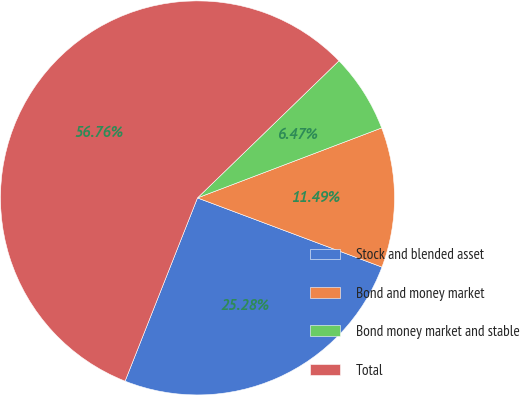Convert chart. <chart><loc_0><loc_0><loc_500><loc_500><pie_chart><fcel>Stock and blended asset<fcel>Bond and money market<fcel>Bond money market and stable<fcel>Total<nl><fcel>25.28%<fcel>11.49%<fcel>6.47%<fcel>56.76%<nl></chart> 